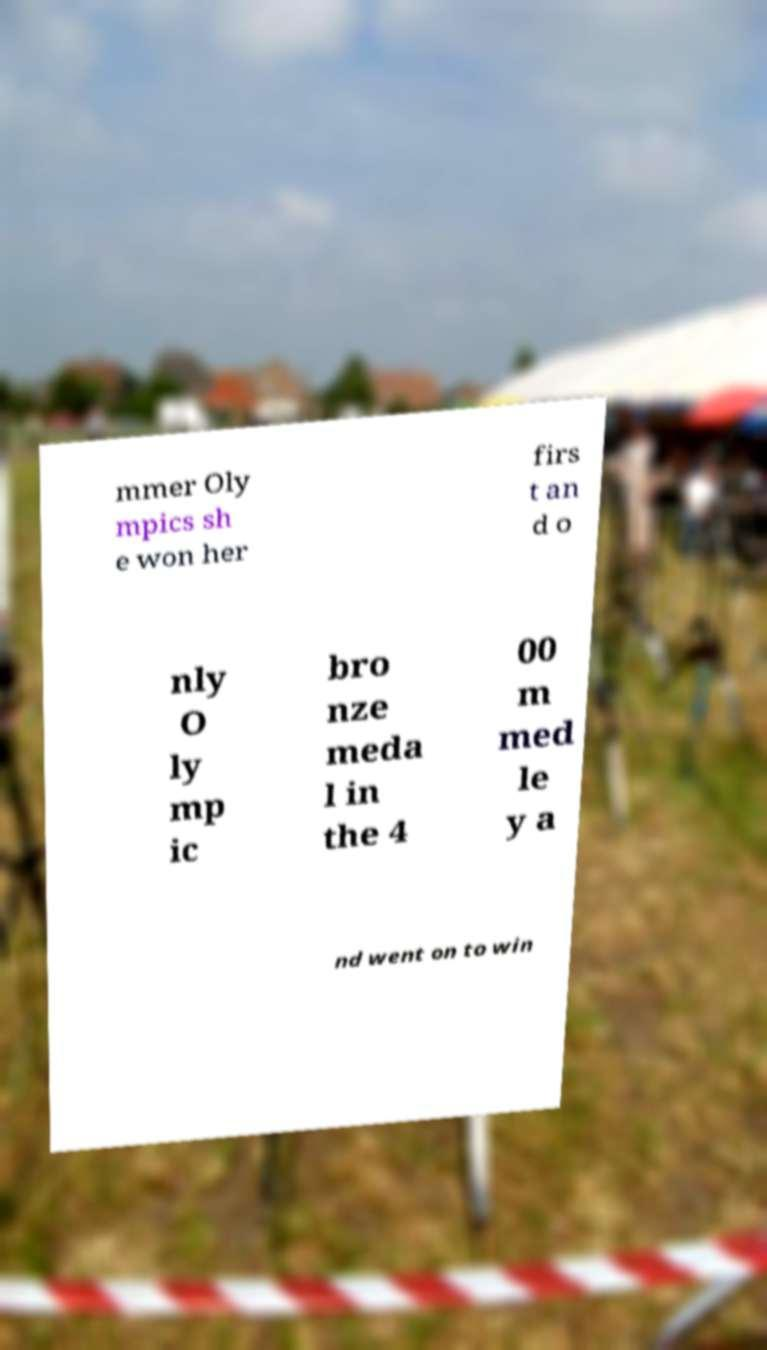For documentation purposes, I need the text within this image transcribed. Could you provide that? mmer Oly mpics sh e won her firs t an d o nly O ly mp ic bro nze meda l in the 4 00 m med le y a nd went on to win 